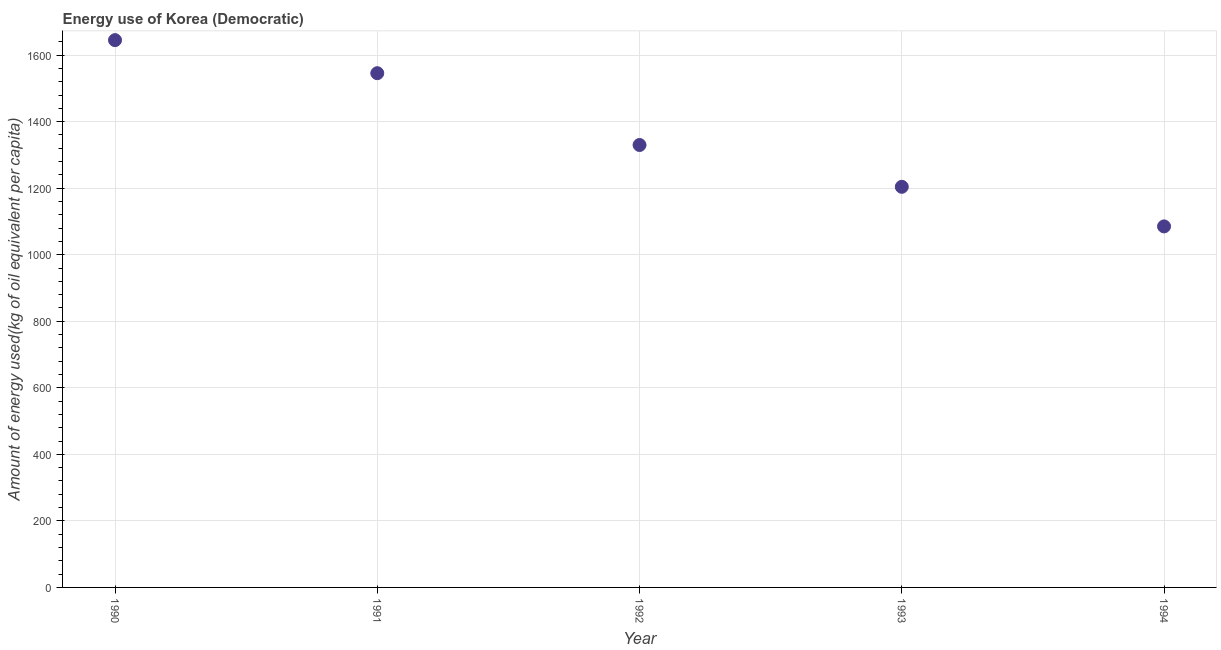What is the amount of energy used in 1993?
Offer a very short reply. 1204.22. Across all years, what is the maximum amount of energy used?
Your answer should be compact. 1645.12. Across all years, what is the minimum amount of energy used?
Provide a succinct answer. 1085.21. In which year was the amount of energy used maximum?
Your answer should be very brief. 1990. In which year was the amount of energy used minimum?
Provide a succinct answer. 1994. What is the sum of the amount of energy used?
Ensure brevity in your answer.  6810.22. What is the difference between the amount of energy used in 1991 and 1992?
Keep it short and to the point. 215.84. What is the average amount of energy used per year?
Make the answer very short. 1362.04. What is the median amount of energy used?
Your answer should be compact. 1329.92. In how many years, is the amount of energy used greater than 200 kg?
Give a very brief answer. 5. Do a majority of the years between 1994 and 1990 (inclusive) have amount of energy used greater than 1000 kg?
Offer a very short reply. Yes. What is the ratio of the amount of energy used in 1990 to that in 1991?
Make the answer very short. 1.06. What is the difference between the highest and the second highest amount of energy used?
Give a very brief answer. 99.36. Is the sum of the amount of energy used in 1990 and 1994 greater than the maximum amount of energy used across all years?
Your answer should be very brief. Yes. What is the difference between the highest and the lowest amount of energy used?
Make the answer very short. 559.91. What is the difference between two consecutive major ticks on the Y-axis?
Give a very brief answer. 200. Are the values on the major ticks of Y-axis written in scientific E-notation?
Your answer should be very brief. No. What is the title of the graph?
Offer a terse response. Energy use of Korea (Democratic). What is the label or title of the Y-axis?
Provide a succinct answer. Amount of energy used(kg of oil equivalent per capita). What is the Amount of energy used(kg of oil equivalent per capita) in 1990?
Make the answer very short. 1645.12. What is the Amount of energy used(kg of oil equivalent per capita) in 1991?
Your answer should be very brief. 1545.76. What is the Amount of energy used(kg of oil equivalent per capita) in 1992?
Ensure brevity in your answer.  1329.92. What is the Amount of energy used(kg of oil equivalent per capita) in 1993?
Offer a terse response. 1204.22. What is the Amount of energy used(kg of oil equivalent per capita) in 1994?
Make the answer very short. 1085.21. What is the difference between the Amount of energy used(kg of oil equivalent per capita) in 1990 and 1991?
Offer a very short reply. 99.36. What is the difference between the Amount of energy used(kg of oil equivalent per capita) in 1990 and 1992?
Your response must be concise. 315.2. What is the difference between the Amount of energy used(kg of oil equivalent per capita) in 1990 and 1993?
Ensure brevity in your answer.  440.89. What is the difference between the Amount of energy used(kg of oil equivalent per capita) in 1990 and 1994?
Provide a succinct answer. 559.91. What is the difference between the Amount of energy used(kg of oil equivalent per capita) in 1991 and 1992?
Ensure brevity in your answer.  215.84. What is the difference between the Amount of energy used(kg of oil equivalent per capita) in 1991 and 1993?
Ensure brevity in your answer.  341.53. What is the difference between the Amount of energy used(kg of oil equivalent per capita) in 1991 and 1994?
Provide a short and direct response. 460.55. What is the difference between the Amount of energy used(kg of oil equivalent per capita) in 1992 and 1993?
Give a very brief answer. 125.7. What is the difference between the Amount of energy used(kg of oil equivalent per capita) in 1992 and 1994?
Provide a succinct answer. 244.71. What is the difference between the Amount of energy used(kg of oil equivalent per capita) in 1993 and 1994?
Your answer should be very brief. 119.02. What is the ratio of the Amount of energy used(kg of oil equivalent per capita) in 1990 to that in 1991?
Your response must be concise. 1.06. What is the ratio of the Amount of energy used(kg of oil equivalent per capita) in 1990 to that in 1992?
Provide a short and direct response. 1.24. What is the ratio of the Amount of energy used(kg of oil equivalent per capita) in 1990 to that in 1993?
Offer a very short reply. 1.37. What is the ratio of the Amount of energy used(kg of oil equivalent per capita) in 1990 to that in 1994?
Ensure brevity in your answer.  1.52. What is the ratio of the Amount of energy used(kg of oil equivalent per capita) in 1991 to that in 1992?
Your answer should be compact. 1.16. What is the ratio of the Amount of energy used(kg of oil equivalent per capita) in 1991 to that in 1993?
Keep it short and to the point. 1.28. What is the ratio of the Amount of energy used(kg of oil equivalent per capita) in 1991 to that in 1994?
Offer a terse response. 1.42. What is the ratio of the Amount of energy used(kg of oil equivalent per capita) in 1992 to that in 1993?
Keep it short and to the point. 1.1. What is the ratio of the Amount of energy used(kg of oil equivalent per capita) in 1992 to that in 1994?
Your response must be concise. 1.23. What is the ratio of the Amount of energy used(kg of oil equivalent per capita) in 1993 to that in 1994?
Ensure brevity in your answer.  1.11. 